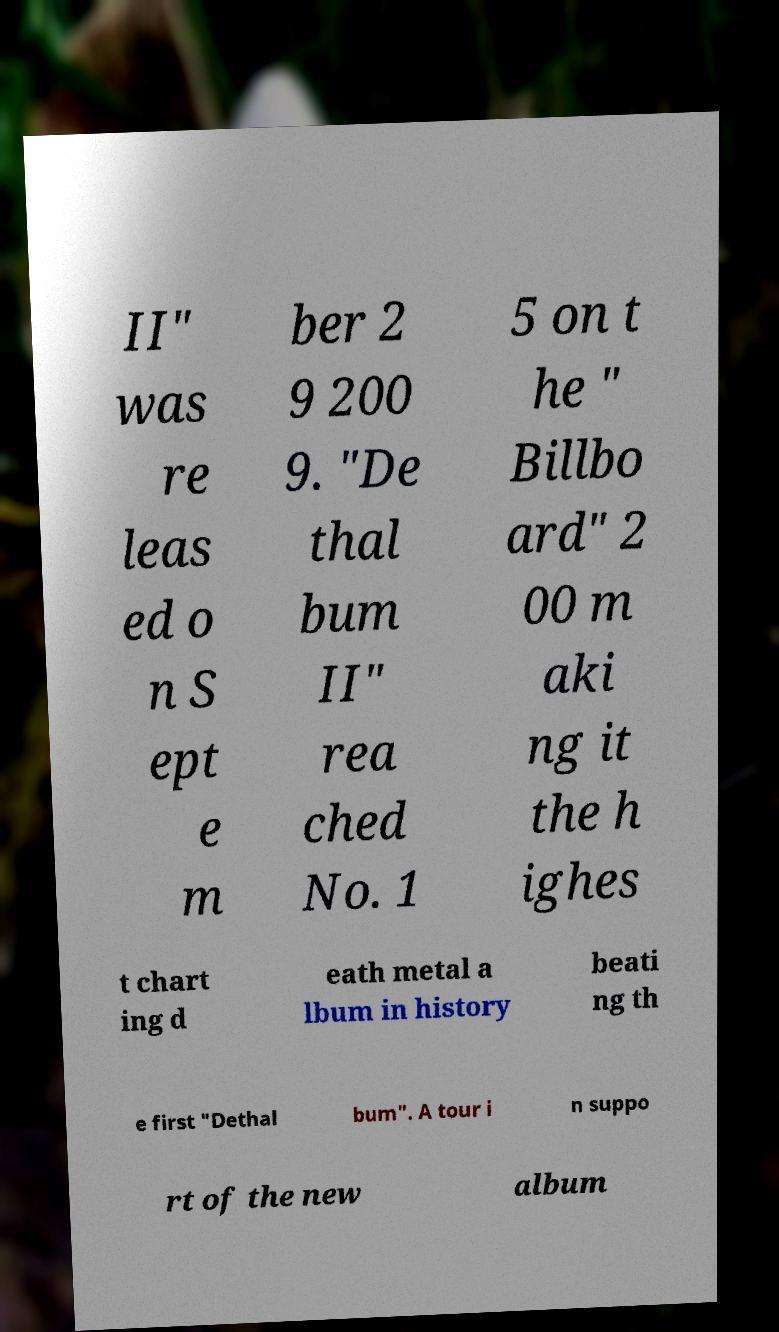What messages or text are displayed in this image? I need them in a readable, typed format. II" was re leas ed o n S ept e m ber 2 9 200 9. "De thal bum II" rea ched No. 1 5 on t he " Billbo ard" 2 00 m aki ng it the h ighes t chart ing d eath metal a lbum in history beati ng th e first "Dethal bum". A tour i n suppo rt of the new album 